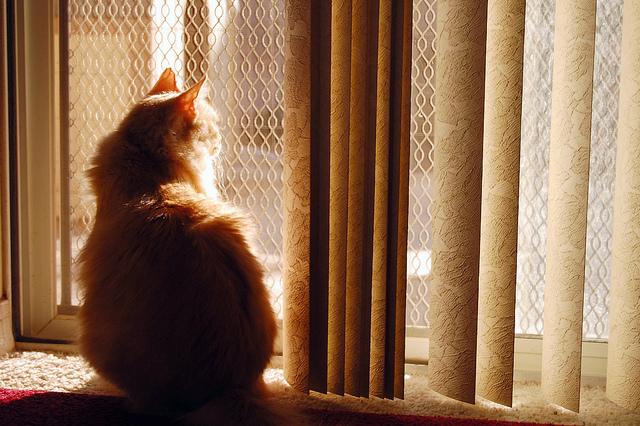Is the cat inside?
Give a very brief answer. Yes. Is the cat waiting for someone?
Short answer required. Yes. What color is the cat?
Keep it brief. Orange. 